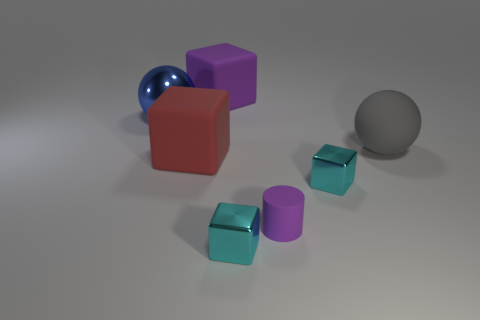How big is the sphere that is in front of the big blue metallic sphere?
Your answer should be compact. Large. There is a gray sphere that is the same material as the cylinder; what size is it?
Offer a very short reply. Large. Are there fewer large blue things than large red matte cylinders?
Your answer should be very brief. No. What is the material of the purple thing that is the same size as the matte sphere?
Make the answer very short. Rubber. Is the number of small yellow cubes greater than the number of metal blocks?
Offer a terse response. No. How many other things are the same color as the tiny matte cylinder?
Provide a short and direct response. 1. How many matte things are both in front of the big blue shiny sphere and left of the gray rubber ball?
Make the answer very short. 2. Is there any other thing that has the same size as the rubber cylinder?
Provide a short and direct response. Yes. Are there more matte blocks that are in front of the large blue metallic ball than tiny purple rubber objects that are behind the purple cylinder?
Ensure brevity in your answer.  Yes. There is a cube that is in front of the tiny rubber cylinder; what is it made of?
Provide a succinct answer. Metal. 